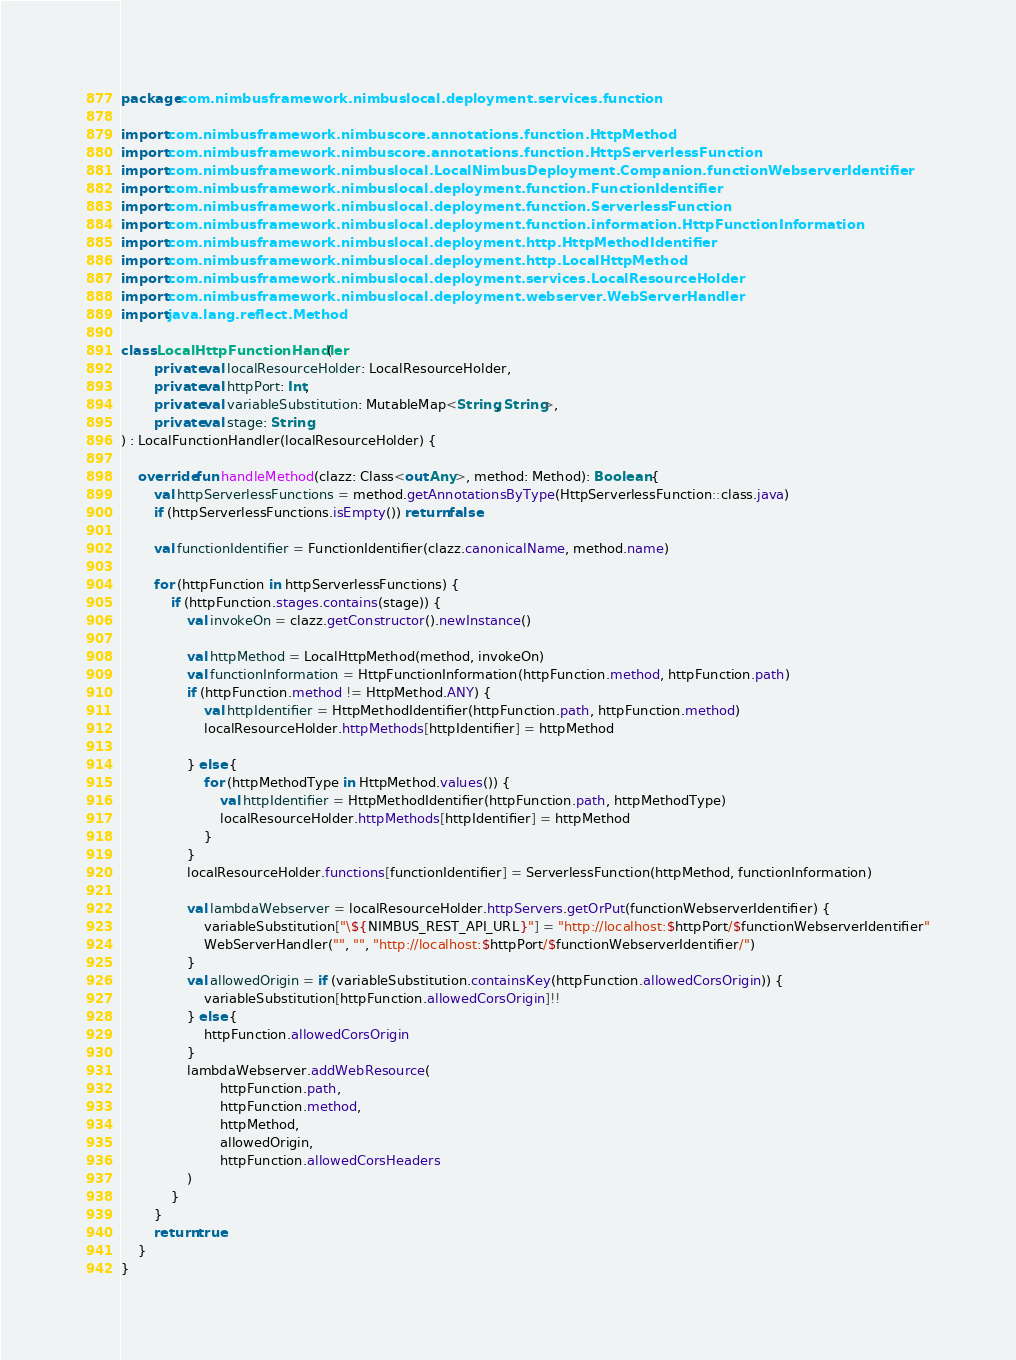Convert code to text. <code><loc_0><loc_0><loc_500><loc_500><_Kotlin_>package com.nimbusframework.nimbuslocal.deployment.services.function

import com.nimbusframework.nimbuscore.annotations.function.HttpMethod
import com.nimbusframework.nimbuscore.annotations.function.HttpServerlessFunction
import com.nimbusframework.nimbuslocal.LocalNimbusDeployment.Companion.functionWebserverIdentifier
import com.nimbusframework.nimbuslocal.deployment.function.FunctionIdentifier
import com.nimbusframework.nimbuslocal.deployment.function.ServerlessFunction
import com.nimbusframework.nimbuslocal.deployment.function.information.HttpFunctionInformation
import com.nimbusframework.nimbuslocal.deployment.http.HttpMethodIdentifier
import com.nimbusframework.nimbuslocal.deployment.http.LocalHttpMethod
import com.nimbusframework.nimbuslocal.deployment.services.LocalResourceHolder
import com.nimbusframework.nimbuslocal.deployment.webserver.WebServerHandler
import java.lang.reflect.Method

class LocalHttpFunctionHandler(
        private val localResourceHolder: LocalResourceHolder,
        private val httpPort: Int,
        private val variableSubstitution: MutableMap<String, String>,
        private val stage: String
) : LocalFunctionHandler(localResourceHolder) {

    override fun handleMethod(clazz: Class<out Any>, method: Method): Boolean {
        val httpServerlessFunctions = method.getAnnotationsByType(HttpServerlessFunction::class.java)
        if (httpServerlessFunctions.isEmpty()) return false

        val functionIdentifier = FunctionIdentifier(clazz.canonicalName, method.name)

        for (httpFunction in httpServerlessFunctions) {
            if (httpFunction.stages.contains(stage)) {
                val invokeOn = clazz.getConstructor().newInstance()

                val httpMethod = LocalHttpMethod(method, invokeOn)
                val functionInformation = HttpFunctionInformation(httpFunction.method, httpFunction.path)
                if (httpFunction.method != HttpMethod.ANY) {
                    val httpIdentifier = HttpMethodIdentifier(httpFunction.path, httpFunction.method)
                    localResourceHolder.httpMethods[httpIdentifier] = httpMethod

                } else {
                    for (httpMethodType in HttpMethod.values()) {
                        val httpIdentifier = HttpMethodIdentifier(httpFunction.path, httpMethodType)
                        localResourceHolder.httpMethods[httpIdentifier] = httpMethod
                    }
                }
                localResourceHolder.functions[functionIdentifier] = ServerlessFunction(httpMethod, functionInformation)

                val lambdaWebserver = localResourceHolder.httpServers.getOrPut(functionWebserverIdentifier) {
                    variableSubstitution["\${NIMBUS_REST_API_URL}"] = "http://localhost:$httpPort/$functionWebserverIdentifier"
                    WebServerHandler("", "", "http://localhost:$httpPort/$functionWebserverIdentifier/")
                }
                val allowedOrigin = if (variableSubstitution.containsKey(httpFunction.allowedCorsOrigin)) {
                    variableSubstitution[httpFunction.allowedCorsOrigin]!!
                } else {
                    httpFunction.allowedCorsOrigin
                }
                lambdaWebserver.addWebResource(
                        httpFunction.path,
                        httpFunction.method,
                        httpMethod,
                        allowedOrigin,
                        httpFunction.allowedCorsHeaders
                )
            }
        }
        return true
    }
}</code> 